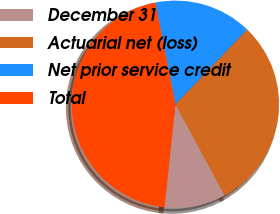Convert chart to OTSL. <chart><loc_0><loc_0><loc_500><loc_500><pie_chart><fcel>December 31<fcel>Actuarial net (loss)<fcel>Net prior service credit<fcel>Total<nl><fcel>9.54%<fcel>29.97%<fcel>15.26%<fcel>45.23%<nl></chart> 